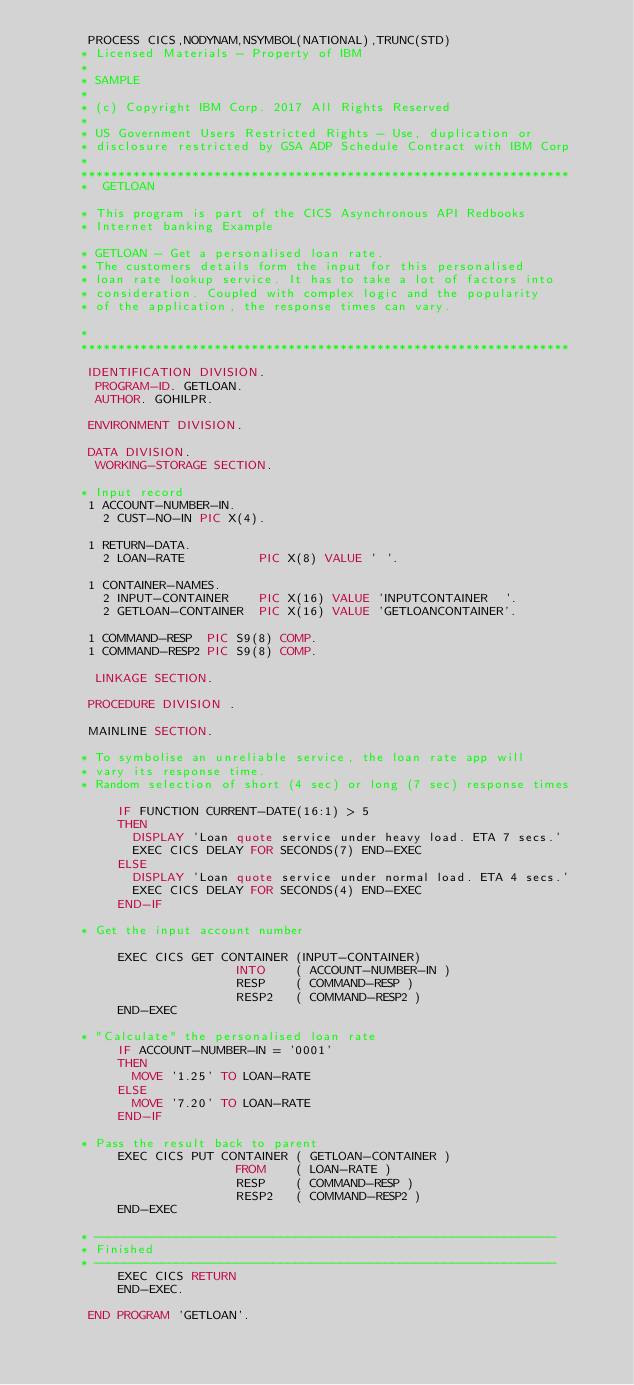Convert code to text. <code><loc_0><loc_0><loc_500><loc_500><_COBOL_>       PROCESS CICS,NODYNAM,NSYMBOL(NATIONAL),TRUNC(STD)
      * Licensed Materials - Property of IBM
      *
      * SAMPLE
      *
      * (c) Copyright IBM Corp. 2017 All Rights Reserved
      *
      * US Government Users Restricted Rights - Use, duplication or
      * disclosure restricted by GSA ADP Schedule Contract with IBM Corp
      *
      ******************************************************************
      *  GETLOAN

      * This program is part of the CICS Asynchronous API Redbooks
      * Internet banking Example

      * GETLOAN - Get a personalised loan rate.
      * The customers details form the input for this personalised
      * loan rate lookup service. It has to take a lot of factors into
      * consideration. Coupled with complex logic and the popularity
      * of the application, the response times can vary.

      *
      ******************************************************************

       IDENTIFICATION DIVISION.
        PROGRAM-ID. GETLOAN.
        AUTHOR. GOHILPR.

       ENVIRONMENT DIVISION.

       DATA DIVISION.
        WORKING-STORAGE SECTION.

      * Input record
       1 ACCOUNT-NUMBER-IN.
         2 CUST-NO-IN PIC X(4).

       1 RETURN-DATA.
         2 LOAN-RATE          PIC X(8) VALUE ' '.

       1 CONTAINER-NAMES.
         2 INPUT-CONTAINER    PIC X(16) VALUE 'INPUTCONTAINER  '.
         2 GETLOAN-CONTAINER  PIC X(16) VALUE 'GETLOANCONTAINER'.

       1 COMMAND-RESP  PIC S9(8) COMP.
       1 COMMAND-RESP2 PIC S9(8) COMP.

        LINKAGE SECTION.

       PROCEDURE DIVISION .

       MAINLINE SECTION.

      * To symbolise an unreliable service, the loan rate app will
      * vary its response time.
      * Random selection of short (4 sec) or long (7 sec) response times

           IF FUNCTION CURRENT-DATE(16:1) > 5
           THEN
             DISPLAY 'Loan quote service under heavy load. ETA 7 secs.'
             EXEC CICS DELAY FOR SECONDS(7) END-EXEC
           ELSE
             DISPLAY 'Loan quote service under normal load. ETA 4 secs.'
             EXEC CICS DELAY FOR SECONDS(4) END-EXEC
           END-IF

      * Get the input account number

           EXEC CICS GET CONTAINER (INPUT-CONTAINER)
                           INTO    ( ACCOUNT-NUMBER-IN )
                           RESP    ( COMMAND-RESP )
                           RESP2   ( COMMAND-RESP2 )
           END-EXEC

      * "Calculate" the personalised loan rate
           IF ACCOUNT-NUMBER-IN = '0001'
           THEN
             MOVE '1.25' TO LOAN-RATE
           ELSE
             MOVE '7.20' TO LOAN-RATE
           END-IF

      * Pass the result back to parent
           EXEC CICS PUT CONTAINER ( GETLOAN-CONTAINER )
                           FROM    ( LOAN-RATE )
                           RESP    ( COMMAND-RESP )
                           RESP2   ( COMMAND-RESP2 )
           END-EXEC

      * --------------------------------------------------------------
      * Finished
      * --------------------------------------------------------------
           EXEC CICS RETURN
           END-EXEC.

       END PROGRAM 'GETLOAN'.</code> 